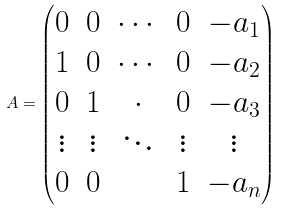Convert formula to latex. <formula><loc_0><loc_0><loc_500><loc_500>A = \begin{pmatrix} 0 & 0 & \cdots & 0 & - a _ { 1 } \\ 1 & 0 & \cdots & 0 & - a _ { 2 } \\ 0 & 1 & \cdot & 0 & - a _ { 3 } \\ \vdots & \vdots & \ddots & \vdots & \vdots \\ 0 & 0 & & 1 & - a _ { n } \end{pmatrix}</formula> 